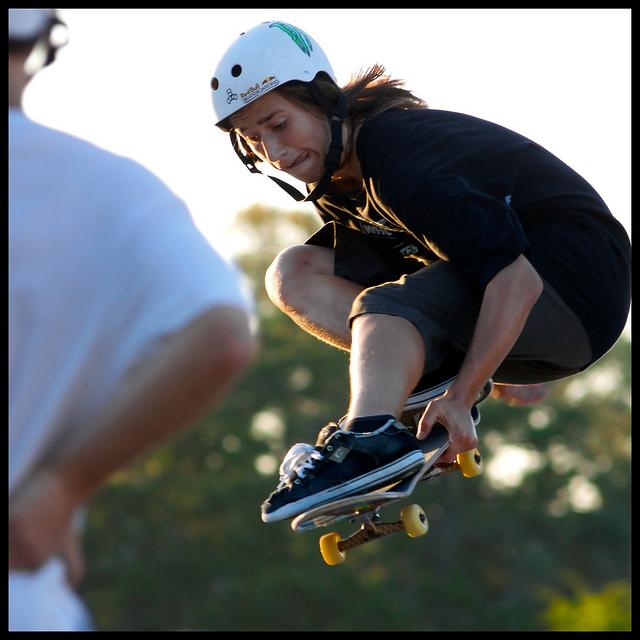What is the person wearing on the head?
Answer briefly. Helmet. Why is the woman wearing a helmet?
Concise answer only. Safety. Are there trees?
Give a very brief answer. Yes. How many photos are present?
Short answer required. 1. 